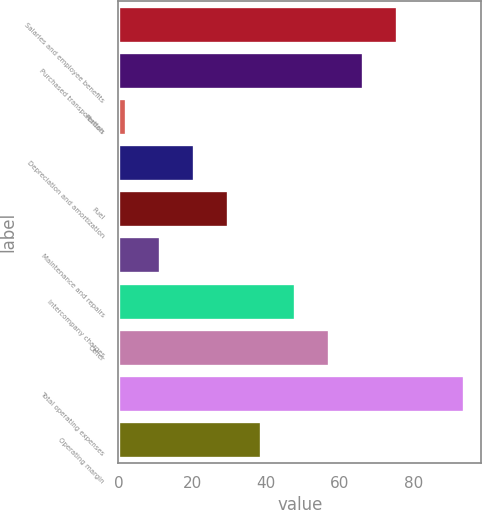<chart> <loc_0><loc_0><loc_500><loc_500><bar_chart><fcel>Salaries and employee benefits<fcel>Purchased transportation<fcel>Rentals<fcel>Depreciation and amortization<fcel>Fuel<fcel>Maintenance and repairs<fcel>Intercompany charges<fcel>Other<fcel>Total operating expenses<fcel>Operating margin<nl><fcel>75.46<fcel>66.29<fcel>2.1<fcel>20.44<fcel>29.61<fcel>11.27<fcel>47.95<fcel>57.12<fcel>93.8<fcel>38.78<nl></chart> 